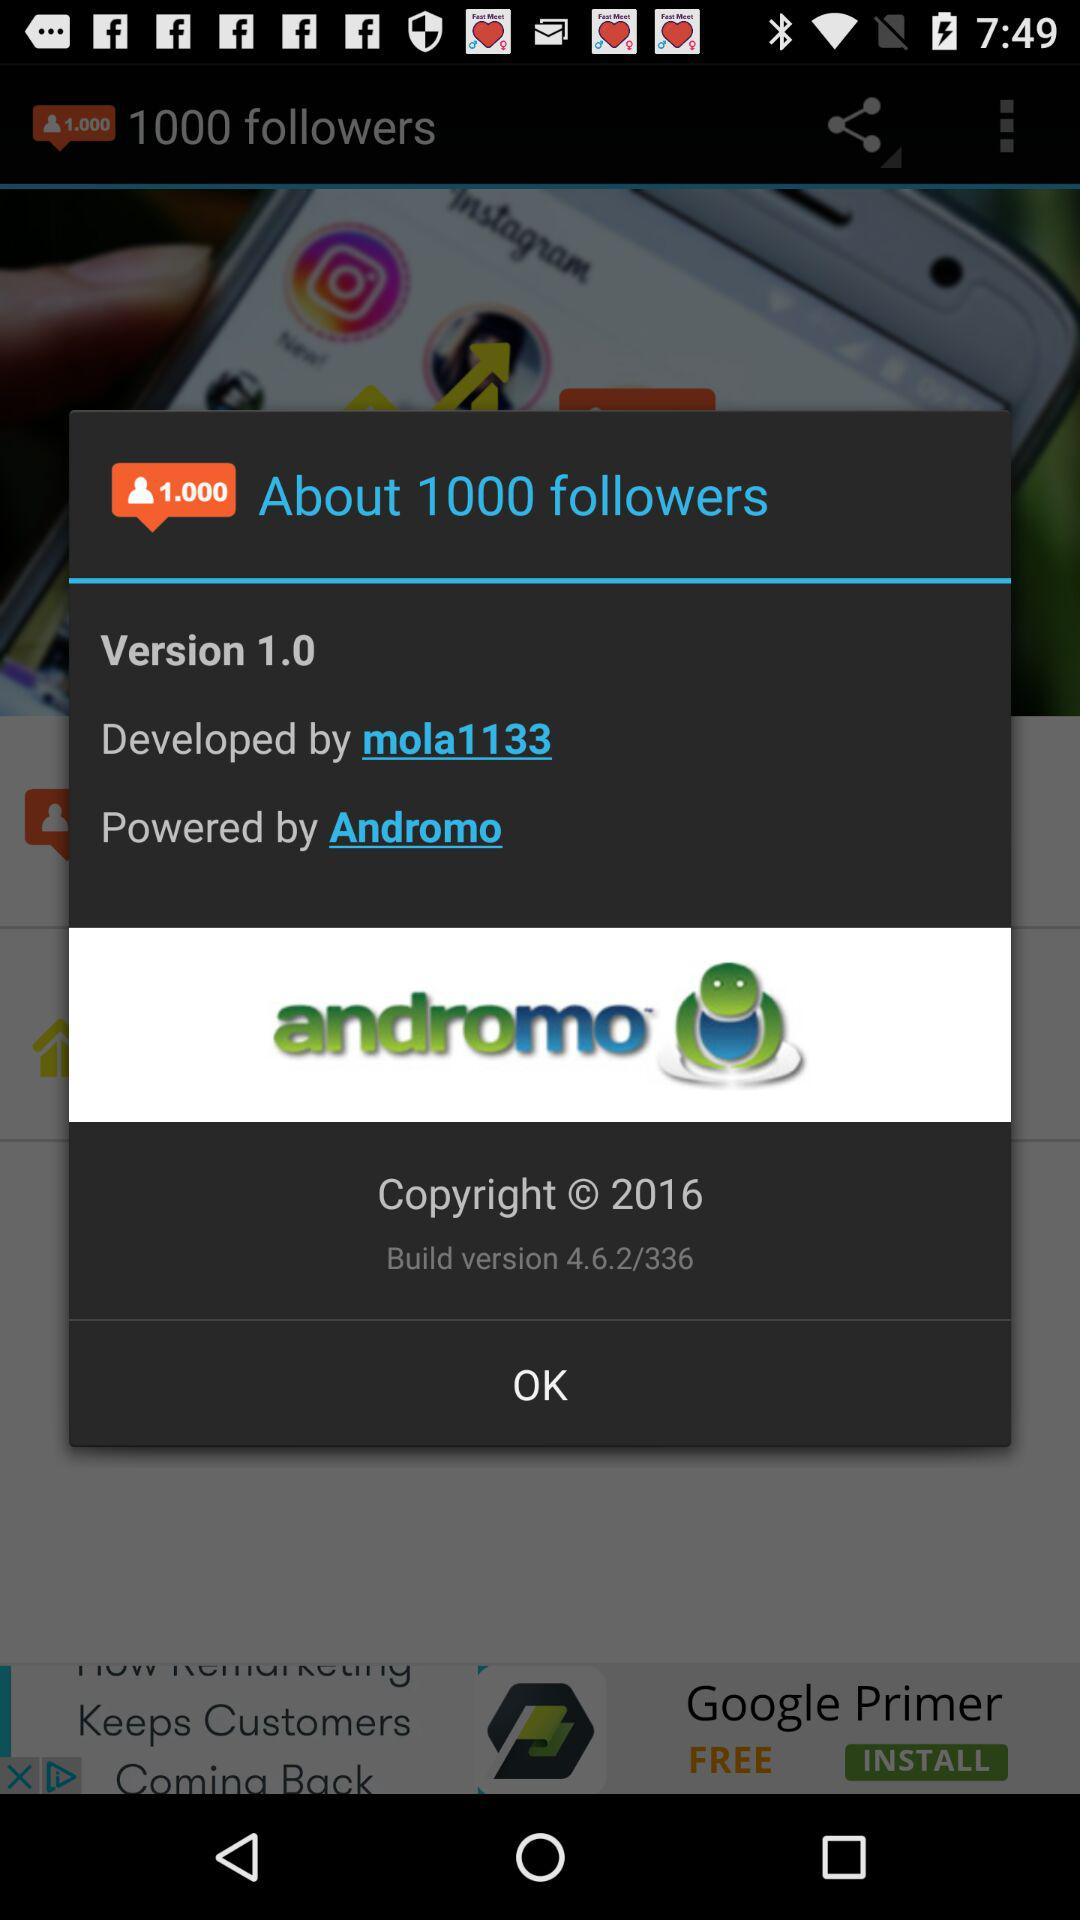By whom was it developed? It was developed by Mola1133. 